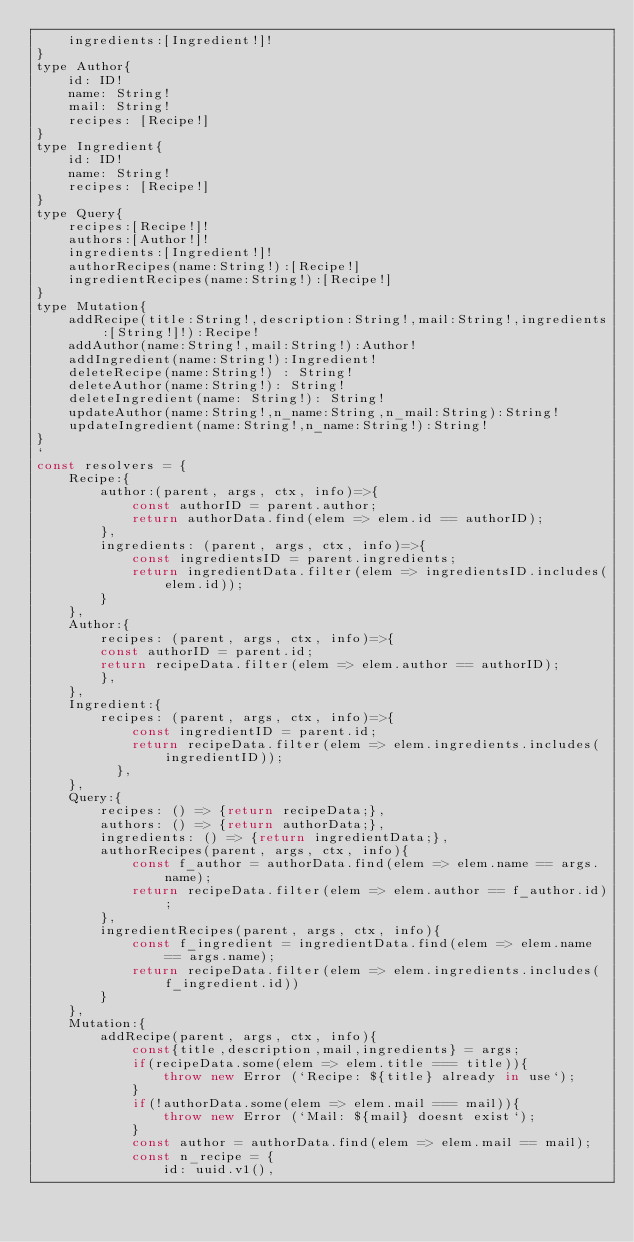Convert code to text. <code><loc_0><loc_0><loc_500><loc_500><_JavaScript_>    ingredients:[Ingredient!]!
}
type Author{
    id: ID!
    name: String!
    mail: String!
    recipes: [Recipe!]
}
type Ingredient{
    id: ID!
    name: String!
    recipes: [Recipe!]
}
type Query{
    recipes:[Recipe!]!
    authors:[Author!]!
    ingredients:[Ingredient!]!
    authorRecipes(name:String!):[Recipe!]
    ingredientRecipes(name:String!):[Recipe!]
}
type Mutation{
    addRecipe(title:String!,description:String!,mail:String!,ingredients:[String!]!):Recipe!
    addAuthor(name:String!,mail:String!):Author!
    addIngredient(name:String!):Ingredient!
    deleteRecipe(name:String!) : String!
    deleteAuthor(name:String!): String!
    deleteIngredient(name: String!): String!
    updateAuthor(name:String!,n_name:String,n_mail:String):String!
    updateIngredient(name:String!,n_name:String!):String!
}
`
const resolvers = {
    Recipe:{
        author:(parent, args, ctx, info)=>{
            const authorID = parent.author;
            return authorData.find(elem => elem.id == authorID);
        },
        ingredients: (parent, args, ctx, info)=>{
            const ingredientsID = parent.ingredients;
            return ingredientData.filter(elem => ingredientsID.includes(elem.id));
        }
    },
    Author:{
        recipes: (parent, args, ctx, info)=>{
        const authorID = parent.id;
        return recipeData.filter(elem => elem.author == authorID);
        },
    },
    Ingredient:{
        recipes: (parent, args, ctx, info)=>{
            const ingredientID = parent.id;
            return recipeData.filter(elem => elem.ingredients.includes(ingredientID));
          },
    },
    Query:{
        recipes: () => {return recipeData;},
        authors: () => {return authorData;},
        ingredients: () => {return ingredientData;},
        authorRecipes(parent, args, ctx, info){
            const f_author = authorData.find(elem => elem.name == args.name);
            return recipeData.filter(elem => elem.author == f_author.id);
        },
        ingredientRecipes(parent, args, ctx, info){
            const f_ingredient = ingredientData.find(elem => elem.name == args.name);
            return recipeData.filter(elem => elem.ingredients.includes(f_ingredient.id))
        }
    },
    Mutation:{
        addRecipe(parent, args, ctx, info){
            const{title,description,mail,ingredients} = args;
            if(recipeData.some(elem => elem.title === title)){
                throw new Error (`Recipe: ${title} already in use`);
            }
            if(!authorData.some(elem => elem.mail === mail)){
                throw new Error (`Mail: ${mail} doesnt exist`);
            }
            const author = authorData.find(elem => elem.mail == mail);
            const n_recipe = {
                id: uuid.v1(),</code> 